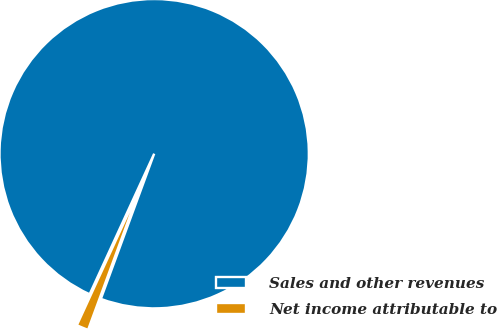Convert chart. <chart><loc_0><loc_0><loc_500><loc_500><pie_chart><fcel>Sales and other revenues<fcel>Net income attributable to<nl><fcel>98.75%<fcel>1.25%<nl></chart> 